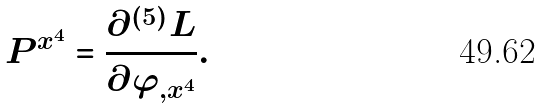<formula> <loc_0><loc_0><loc_500><loc_500>P ^ { x ^ { 4 } } = \frac { \partial ^ { ( 5 ) } L } { \partial \varphi _ { , x ^ { 4 } } } .</formula> 